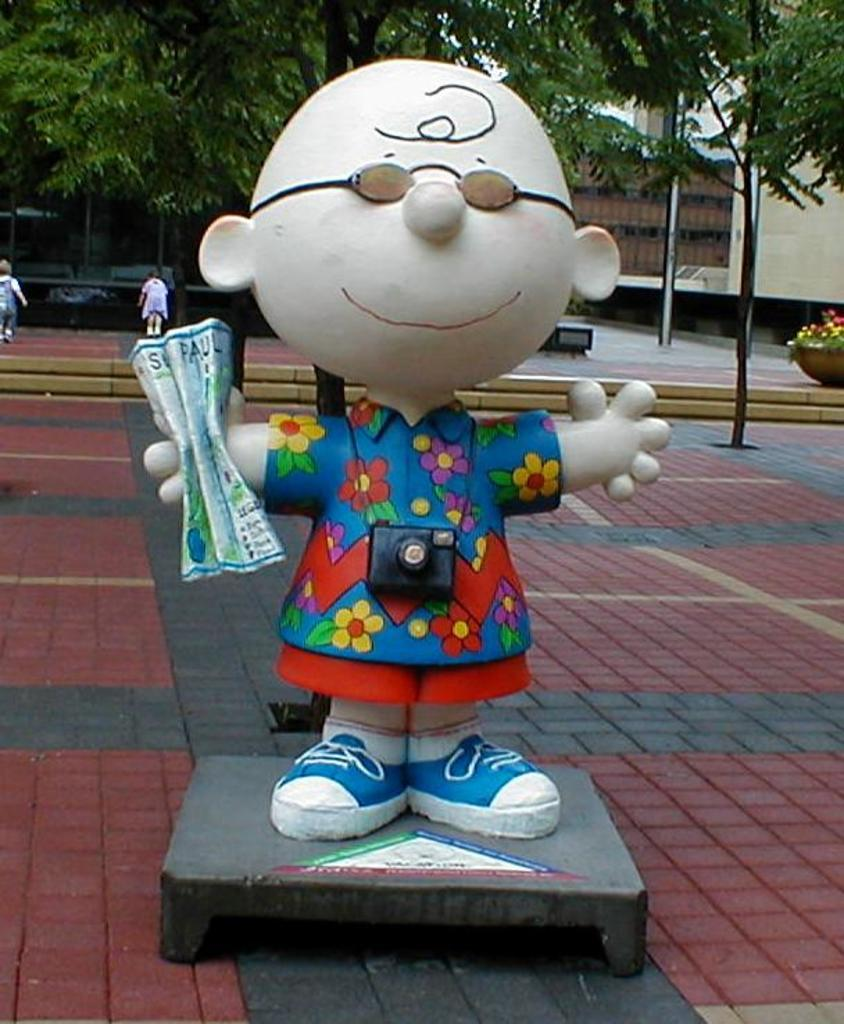What is the main subject in the center of the image? There is a depiction of a person in the center of the image. What can be seen in the background of the image? There are trees and buildings in the background of the image. What type of surface is at the bottom of the image? There is pavement at the bottom of the image. Is the person wearing a crown in the image? There is no crown visible on the person in the image. What date is marked on the calendar in the image? There is no calendar present in the image. 